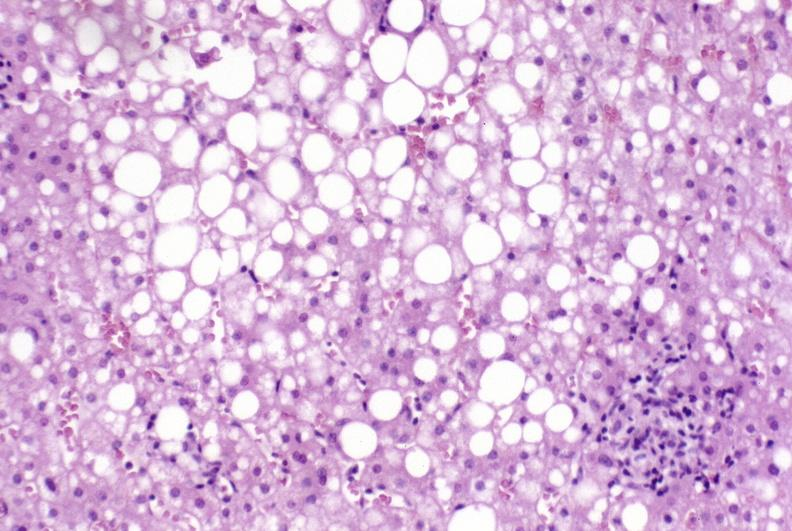s hepatobiliary present?
Answer the question using a single word or phrase. Yes 